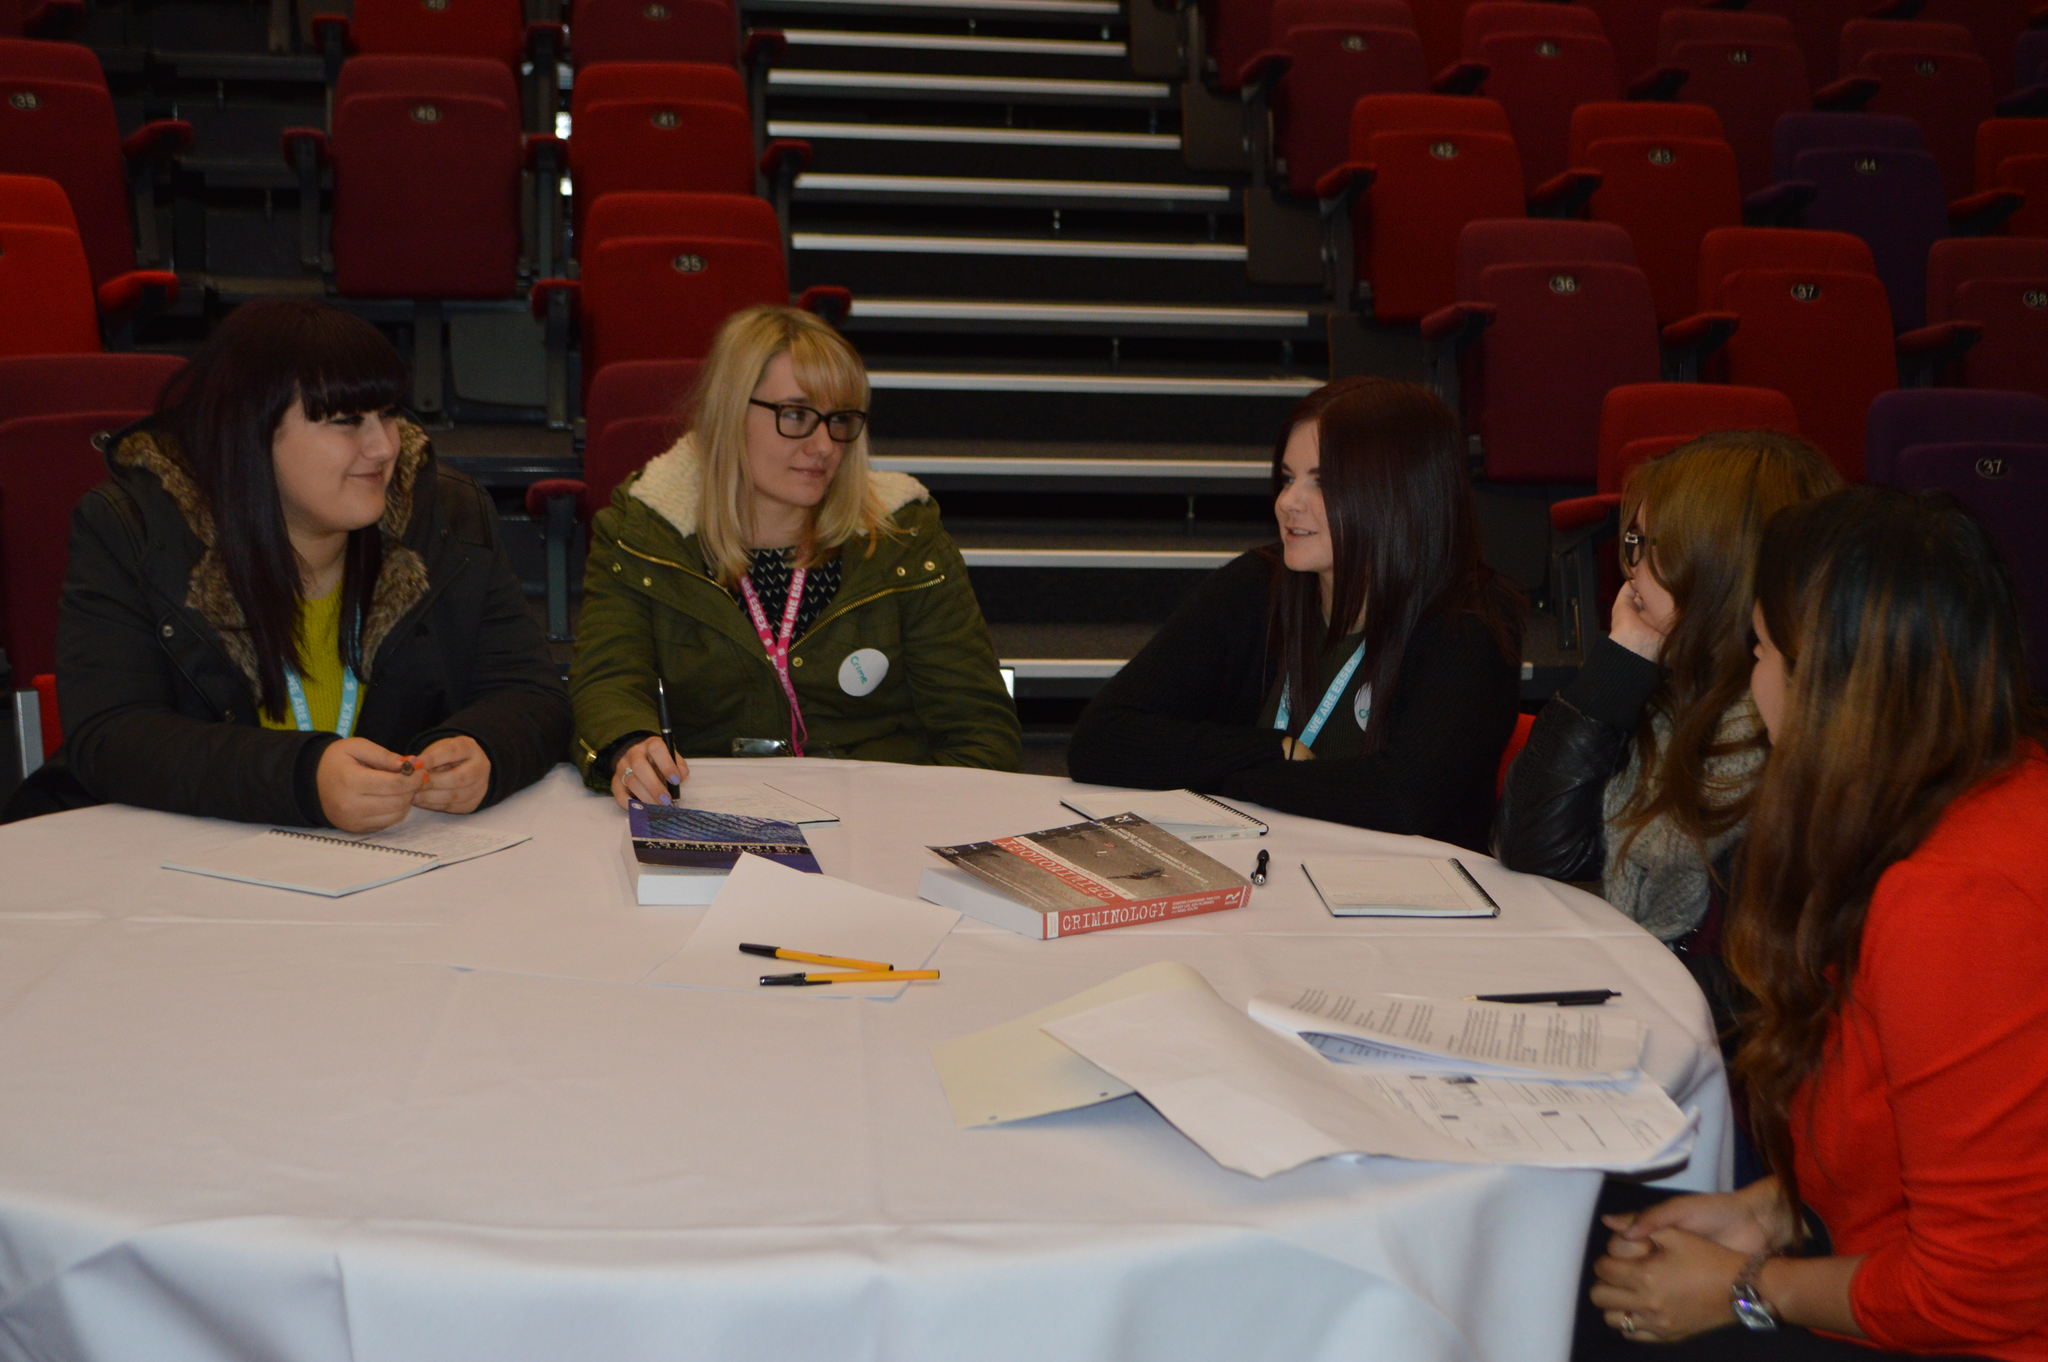Describe this image in one or two sentences. In this image I can see the group of people sitting In front of the table. On the table there are books,papers and the pens. In the back ground of these people there are chairs and the stairs. 